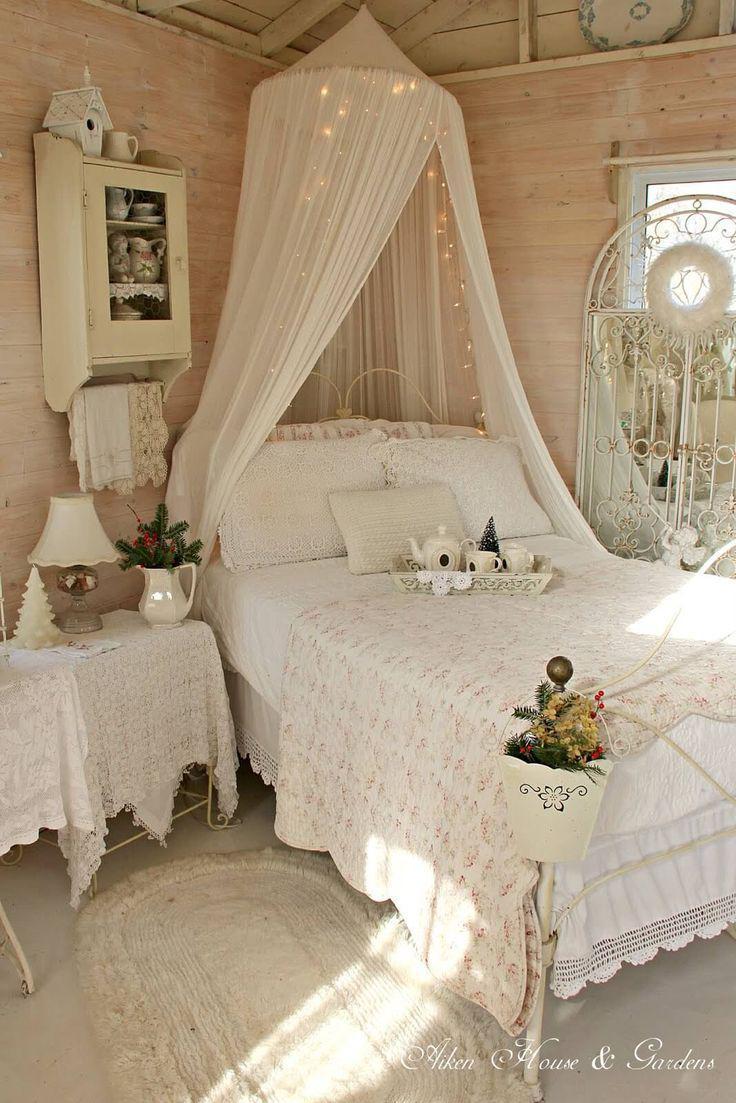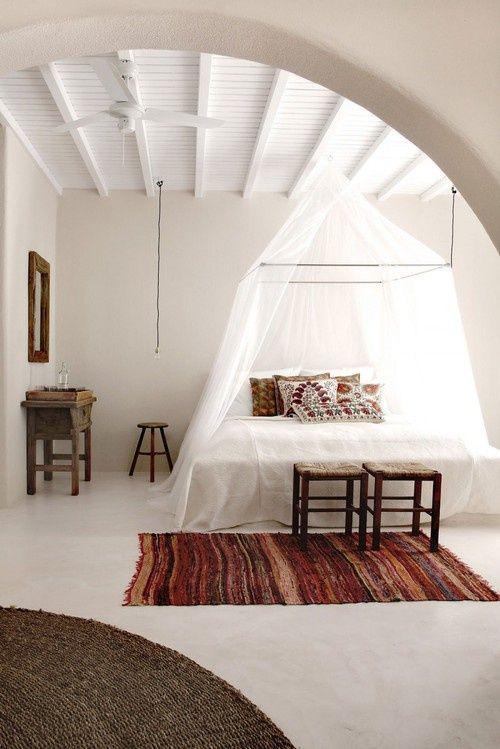The first image is the image on the left, the second image is the image on the right. For the images displayed, is the sentence "There is a table lamp in the image on the left." factually correct? Answer yes or no. Yes. The first image is the image on the left, the second image is the image on the right. Assess this claim about the two images: "At least one bed has a pink canopy.". Correct or not? Answer yes or no. No. 